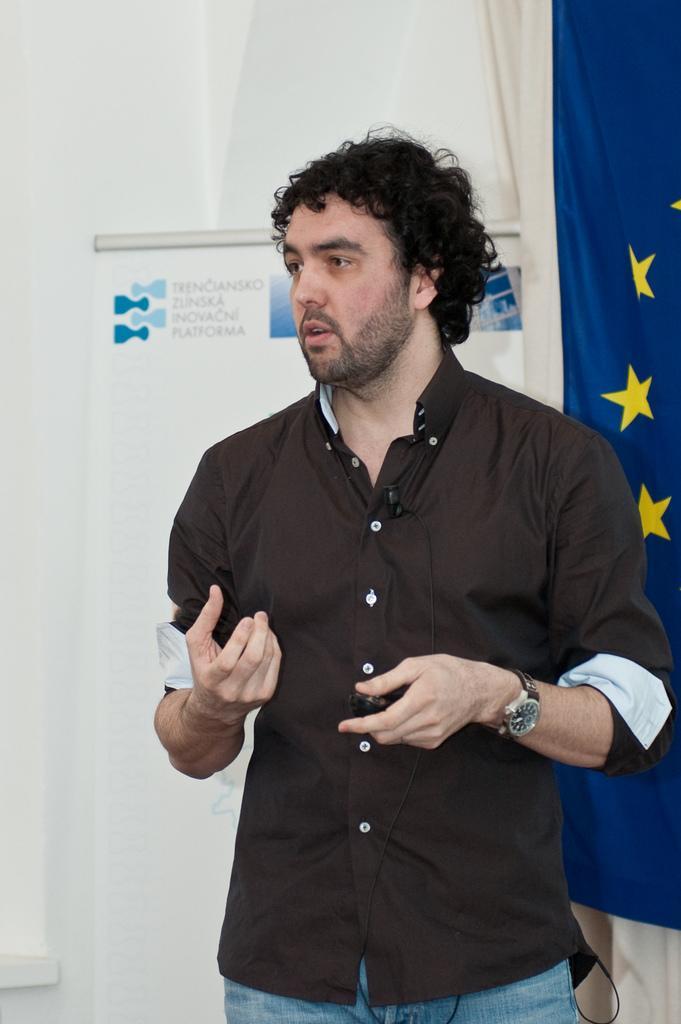In one or two sentences, can you explain what this image depicts? in this image in the front there is a man standing. In the background there is a flag and there is a board which is white in colour with some text written on it and there is a wall which is white in colour. 